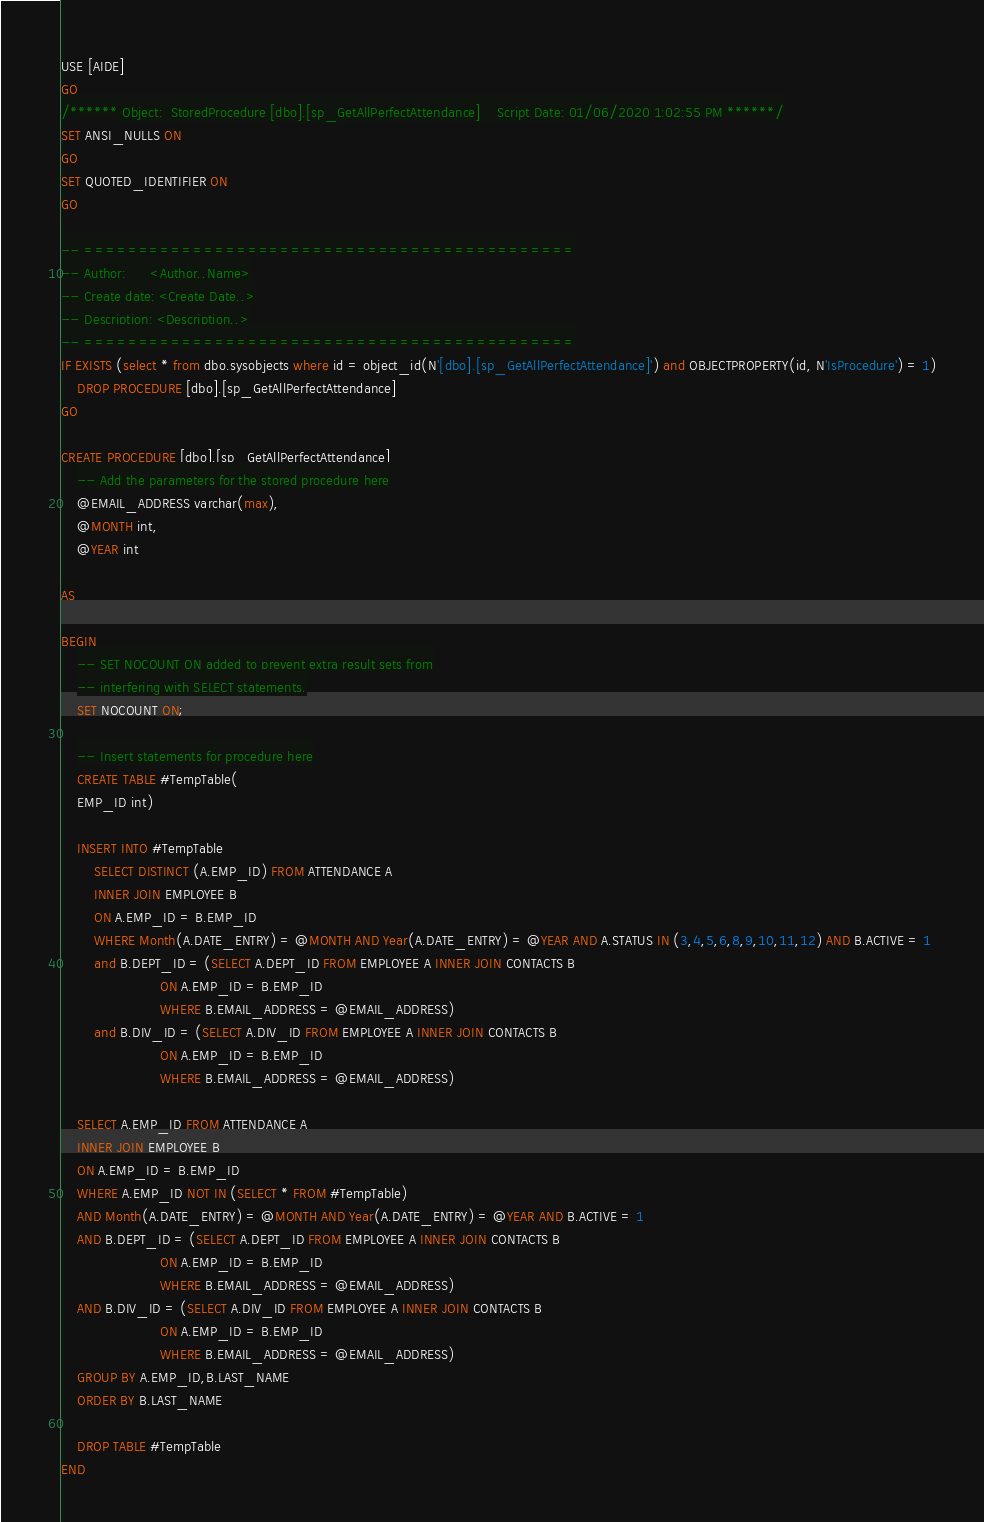Convert code to text. <code><loc_0><loc_0><loc_500><loc_500><_SQL_>USE [AIDE]
GO
/****** Object:  StoredProcedure [dbo].[sp_GetAllPerfectAttendance]    Script Date: 01/06/2020 1:02:55 PM ******/
SET ANSI_NULLS ON
GO
SET QUOTED_IDENTIFIER ON
GO

-- =============================================
-- Author:		<Author,,Name>
-- Create date: <Create Date,,>
-- Description:	<Description,,>
-- =============================================
IF EXISTS (select * from dbo.sysobjects where id = object_id(N'[dbo].[sp_GetAllPerfectAttendance]') and OBJECTPROPERTY(id, N'IsProcedure') = 1)
	DROP PROCEDURE [dbo].[sp_GetAllPerfectAttendance]
GO

CREATE PROCEDURE [dbo].[sp_GetAllPerfectAttendance]
	-- Add the parameters for the stored procedure here
	@EMAIL_ADDRESS varchar(max),
	@MONTH int,
	@YEAR int

AS

BEGIN
	-- SET NOCOUNT ON added to prevent extra result sets from
	-- interfering with SELECT statements.
	SET NOCOUNT ON;

    -- Insert statements for procedure here
	CREATE TABLE #TempTable(
	EMP_ID int)

	INSERT INTO #TempTable
		SELECT DISTINCT (A.EMP_ID) FROM ATTENDANCE A
		INNER JOIN EMPLOYEE B
		ON A.EMP_ID = B.EMP_ID
		WHERE Month(A.DATE_ENTRY) = @MONTH AND Year(A.DATE_ENTRY) = @YEAR AND A.STATUS IN (3,4,5,6,8,9,10,11,12) AND B.ACTIVE = 1
		and B.DEPT_ID = (SELECT A.DEPT_ID FROM EMPLOYEE A INNER JOIN CONTACTS B
						ON A.EMP_ID = B.EMP_ID
						WHERE B.EMAIL_ADDRESS = @EMAIL_ADDRESS)
		and B.DIV_ID = (SELECT A.DIV_ID FROM EMPLOYEE A INNER JOIN CONTACTS B
						ON A.EMP_ID = B.EMP_ID
						WHERE B.EMAIL_ADDRESS = @EMAIL_ADDRESS)

	SELECT A.EMP_ID FROM ATTENDANCE A
	INNER JOIN EMPLOYEE B
	ON A.EMP_ID = B.EMP_ID
	WHERE A.EMP_ID NOT IN (SELECT * FROM #TempTable)
	AND Month(A.DATE_ENTRY) = @MONTH AND Year(A.DATE_ENTRY) = @YEAR AND B.ACTIVE = 1
	AND B.DEPT_ID = (SELECT A.DEPT_ID FROM EMPLOYEE A INNER JOIN CONTACTS B
						ON A.EMP_ID = B.EMP_ID
						WHERE B.EMAIL_ADDRESS = @EMAIL_ADDRESS)
	AND B.DIV_ID = (SELECT A.DIV_ID FROM EMPLOYEE A INNER JOIN CONTACTS B
						ON A.EMP_ID = B.EMP_ID
						WHERE B.EMAIL_ADDRESS = @EMAIL_ADDRESS)
	GROUP BY A.EMP_ID,B.LAST_NAME
	ORDER BY B.LAST_NAME

	DROP TABLE #TempTable
END


</code> 